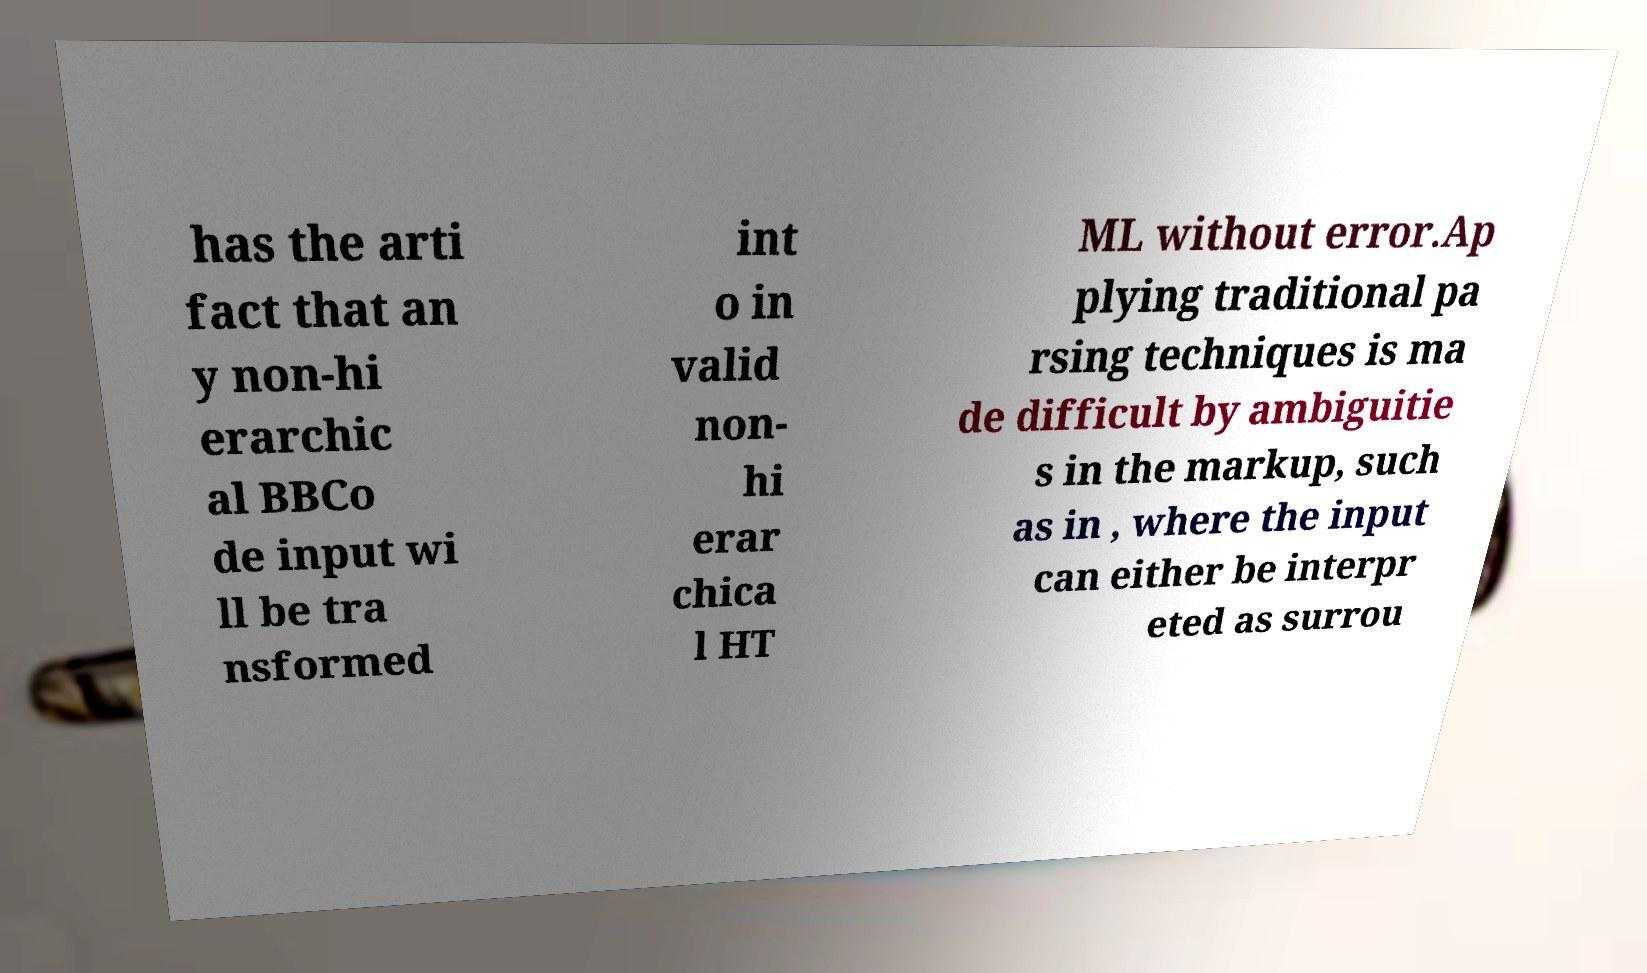Could you extract and type out the text from this image? has the arti fact that an y non-hi erarchic al BBCo de input wi ll be tra nsformed int o in valid non- hi erar chica l HT ML without error.Ap plying traditional pa rsing techniques is ma de difficult by ambiguitie s in the markup, such as in , where the input can either be interpr eted as surrou 